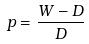<formula> <loc_0><loc_0><loc_500><loc_500>p = \frac { W - D } { D }</formula> 